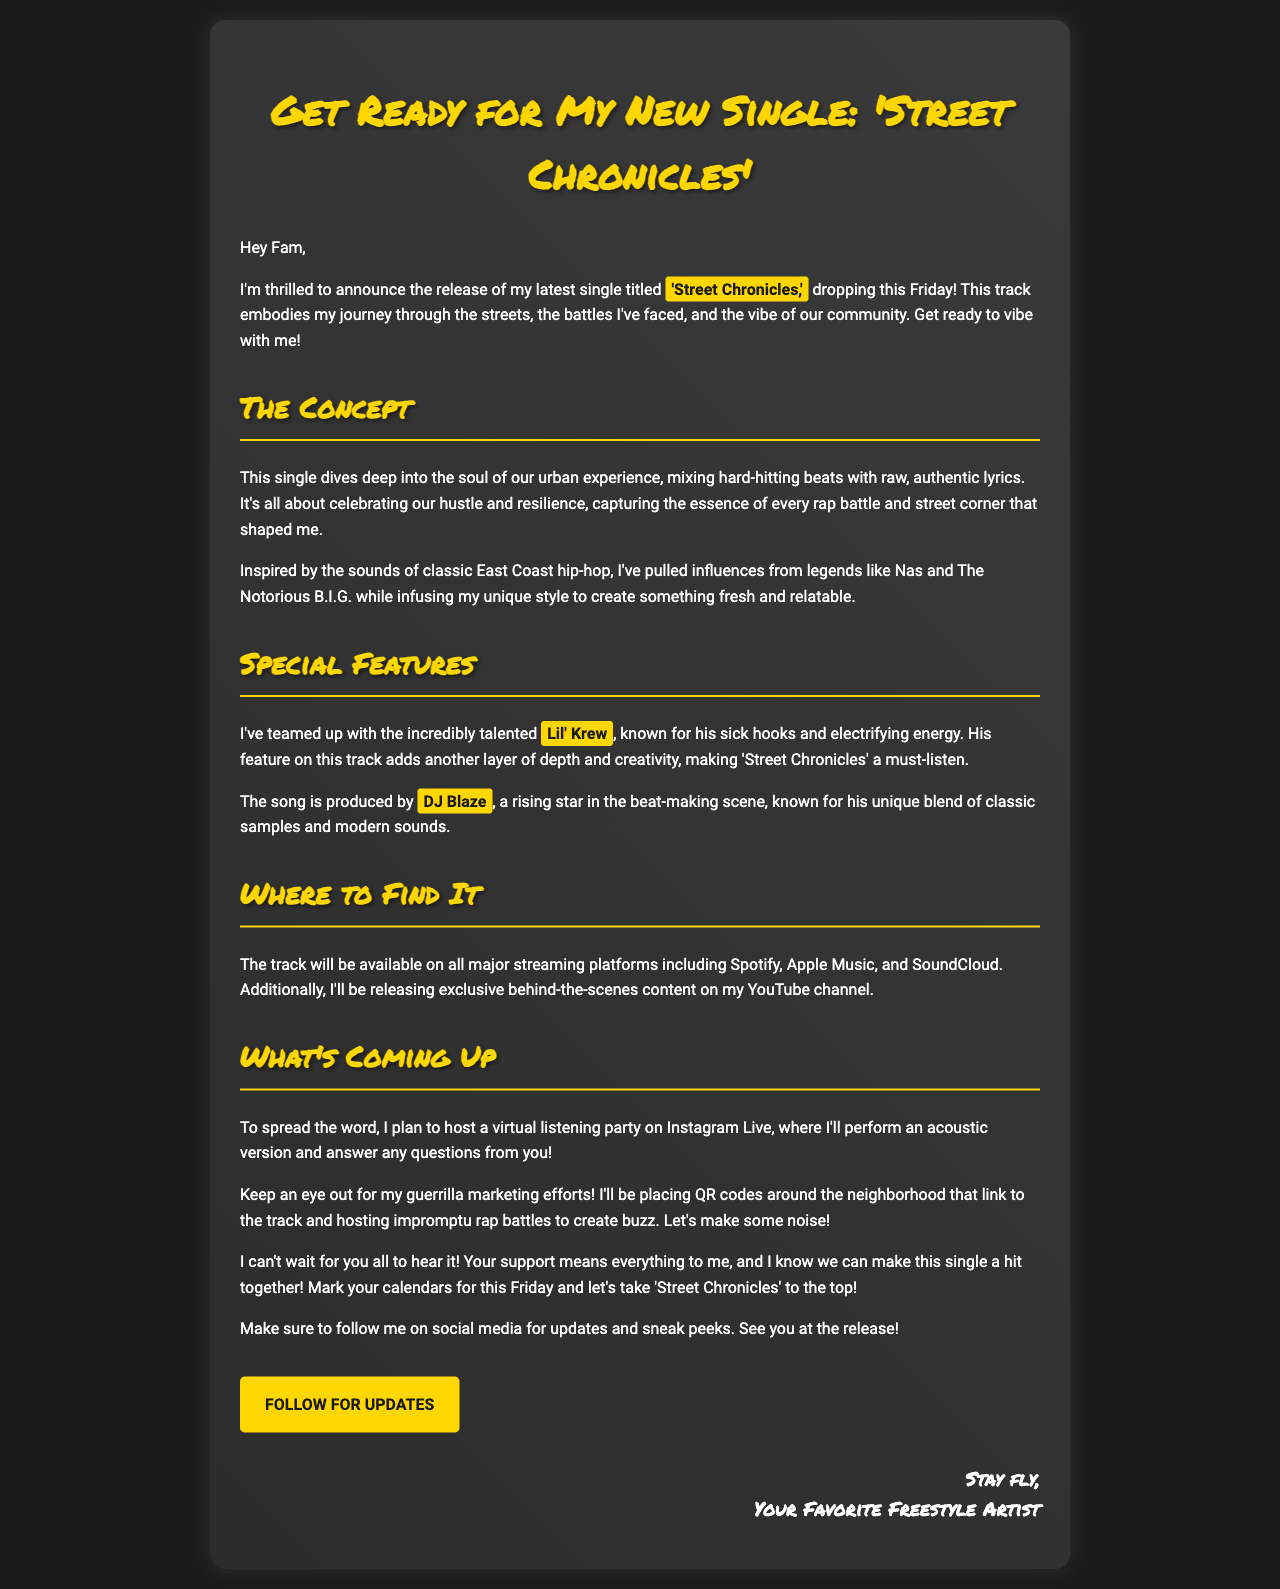What is the title of the new single? The title of the new single is mentioned in the announcement, which is 'Street Chronicles'.
Answer: 'Street Chronicles' Who collaborated with the artist on this track? The email states that the artist collaborated with Lil' Krew, who is known for his sick hooks and electrifying energy.
Answer: Lil' Krew When is the track releasing? The document explicitly mentions that the track is dropping this Friday.
Answer: This Friday What genre influences the new single? The email discusses that the single is inspired by classic East Coast hip-hop.
Answer: East Coast hip-hop Which producer worked on 'Street Chronicles'? The document identifies DJ Blaze as the producer of the track.
Answer: DJ Blaze What kind of event is planned for the release? The artist plans to host a virtual listening party on Instagram Live for the release.
Answer: Virtual listening party Where will 'Street Chronicles' be available? The email lists major streaming platforms where the track will be available, including Spotify, Apple Music, and SoundCloud.
Answer: Spotify, Apple Music, SoundCloud What type of marketing efforts are mentioned? The document refers to guerrilla marketing efforts and placing QR codes around the neighborhood.
Answer: Guerrilla marketing efforts, QR codes 